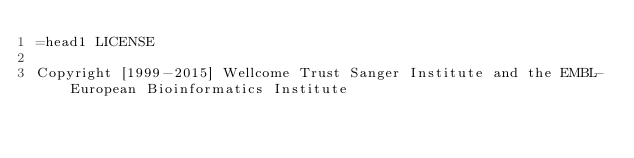<code> <loc_0><loc_0><loc_500><loc_500><_Perl_>=head1 LICENSE

Copyright [1999-2015] Wellcome Trust Sanger Institute and the EMBL-European Bioinformatics Institute</code> 